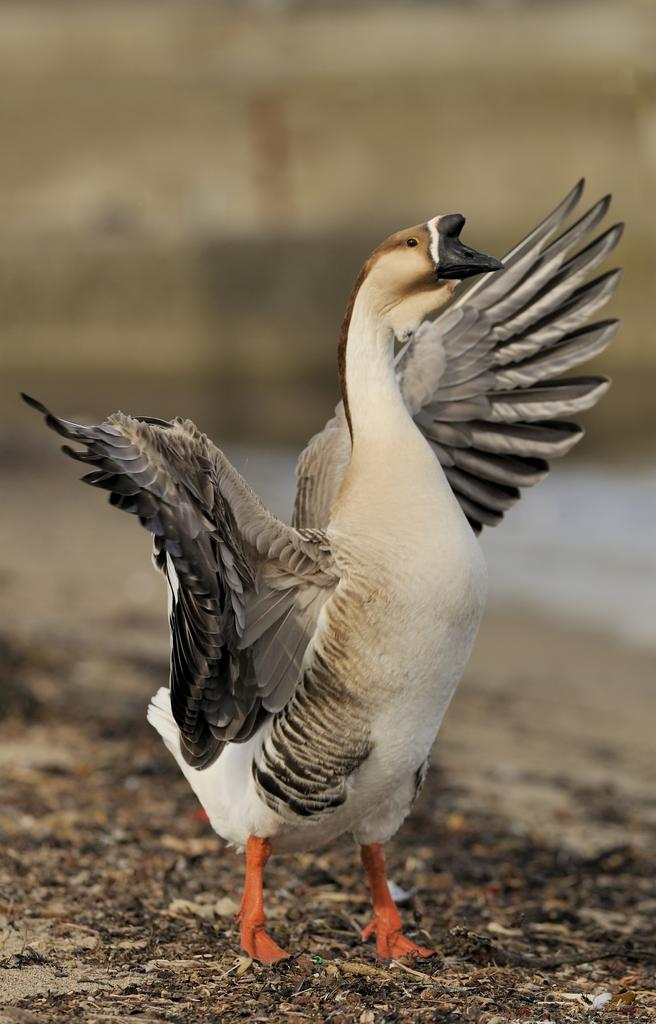What animal is present in the image? There is a duck in the picture. Can you describe the color of the duck in the image? The duck has a white and brown color. Where is the duck located in the image? The duck is standing on the ground. How would you describe the background of the image? The background of the image is blurred. How many oranges are being held by the duck in the image? There are no oranges present in the image; the duck is not holding anything. What type of debt is the duck trying to pay off in the image? There is no reference to debt in the image; it features a duck standing on the ground. 